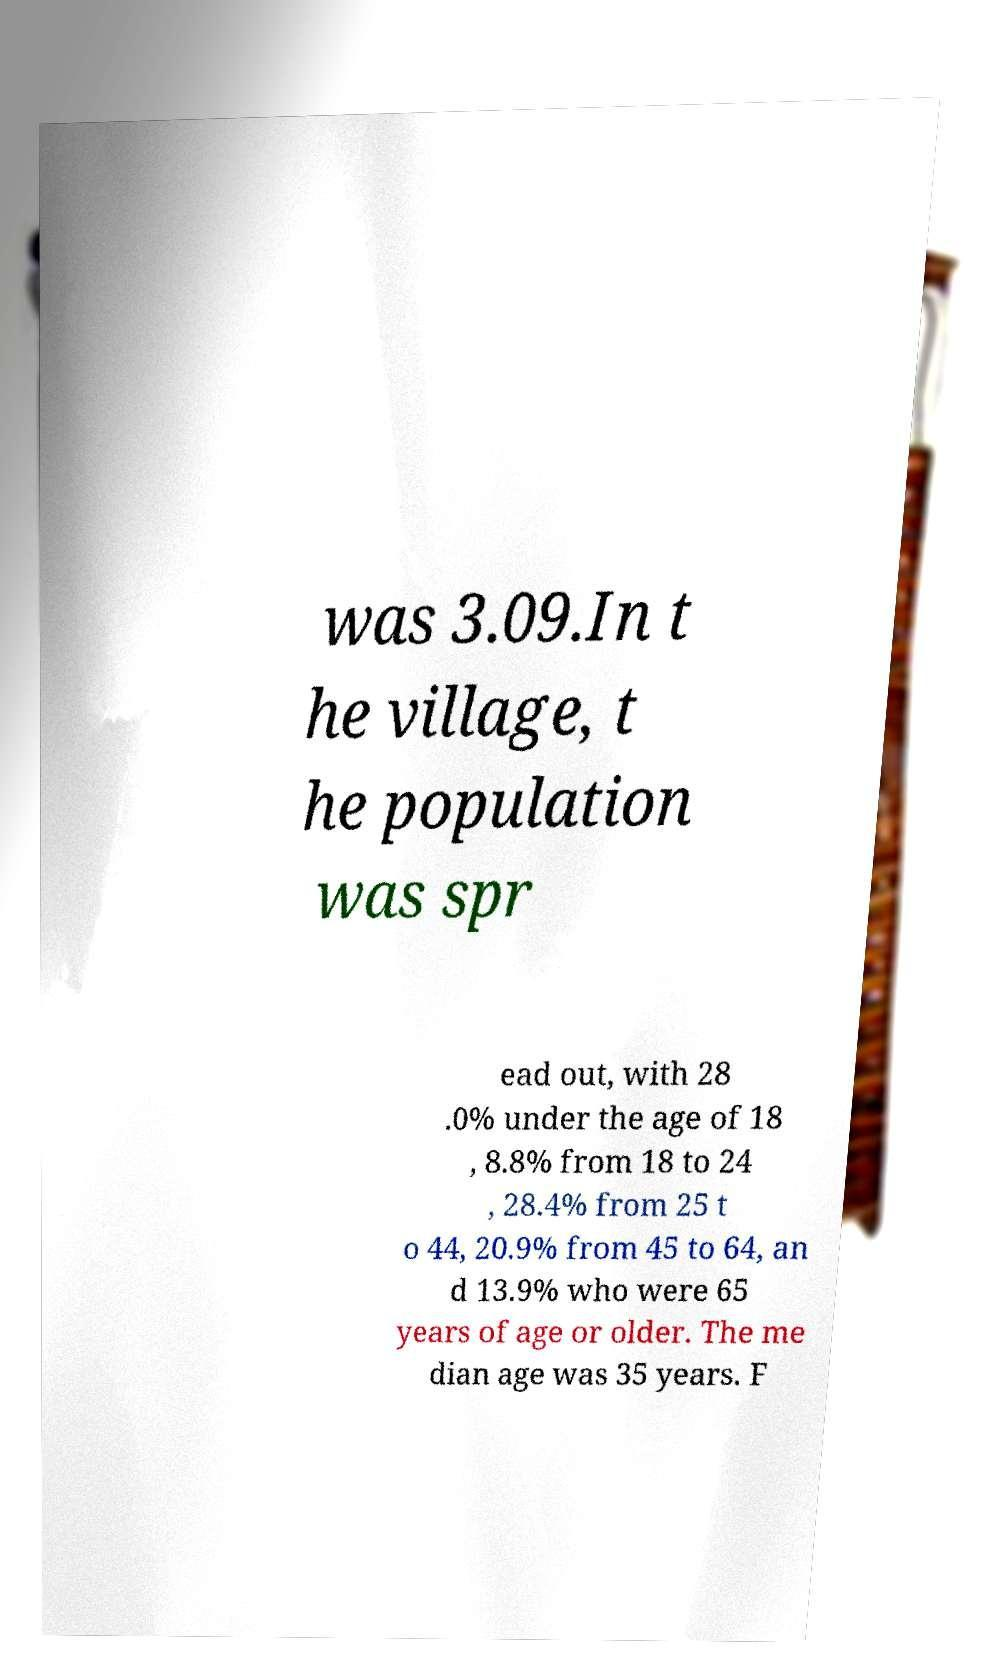For documentation purposes, I need the text within this image transcribed. Could you provide that? was 3.09.In t he village, t he population was spr ead out, with 28 .0% under the age of 18 , 8.8% from 18 to 24 , 28.4% from 25 t o 44, 20.9% from 45 to 64, an d 13.9% who were 65 years of age or older. The me dian age was 35 years. F 